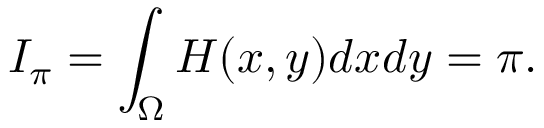Convert formula to latex. <formula><loc_0><loc_0><loc_500><loc_500>I _ { \pi } = \int _ { \Omega } H ( x , y ) d x d y = \pi .</formula> 